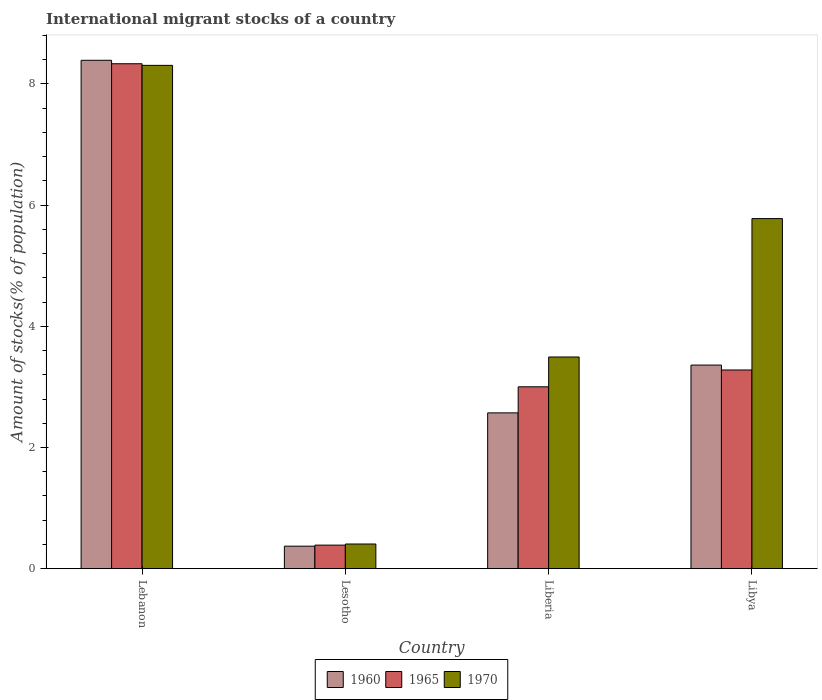How many different coloured bars are there?
Give a very brief answer. 3. How many groups of bars are there?
Your answer should be compact. 4. Are the number of bars on each tick of the X-axis equal?
Your response must be concise. Yes. What is the label of the 1st group of bars from the left?
Offer a terse response. Lebanon. What is the amount of stocks in in 1960 in Lesotho?
Ensure brevity in your answer.  0.37. Across all countries, what is the maximum amount of stocks in in 1970?
Give a very brief answer. 8.31. Across all countries, what is the minimum amount of stocks in in 1965?
Your answer should be very brief. 0.39. In which country was the amount of stocks in in 1970 maximum?
Your answer should be very brief. Lebanon. In which country was the amount of stocks in in 1965 minimum?
Make the answer very short. Lesotho. What is the total amount of stocks in in 1970 in the graph?
Your response must be concise. 17.99. What is the difference between the amount of stocks in in 1960 in Liberia and that in Libya?
Offer a very short reply. -0.79. What is the difference between the amount of stocks in in 1970 in Liberia and the amount of stocks in in 1965 in Lebanon?
Your answer should be very brief. -4.84. What is the average amount of stocks in in 1960 per country?
Give a very brief answer. 3.67. What is the difference between the amount of stocks in of/in 1970 and amount of stocks in of/in 1965 in Lebanon?
Provide a short and direct response. -0.03. What is the ratio of the amount of stocks in in 1960 in Lebanon to that in Lesotho?
Your answer should be compact. 22.57. Is the amount of stocks in in 1965 in Lebanon less than that in Liberia?
Offer a very short reply. No. What is the difference between the highest and the second highest amount of stocks in in 1960?
Your answer should be compact. 5.82. What is the difference between the highest and the lowest amount of stocks in in 1960?
Offer a terse response. 8.02. In how many countries, is the amount of stocks in in 1965 greater than the average amount of stocks in in 1965 taken over all countries?
Your answer should be very brief. 1. What does the 3rd bar from the left in Lesotho represents?
Provide a succinct answer. 1970. What does the 2nd bar from the right in Liberia represents?
Your answer should be very brief. 1965. Is it the case that in every country, the sum of the amount of stocks in in 1970 and amount of stocks in in 1965 is greater than the amount of stocks in in 1960?
Your answer should be very brief. Yes. How many bars are there?
Keep it short and to the point. 12. Are all the bars in the graph horizontal?
Your response must be concise. No. Are the values on the major ticks of Y-axis written in scientific E-notation?
Give a very brief answer. No. Does the graph contain any zero values?
Your answer should be very brief. No. Does the graph contain grids?
Provide a succinct answer. No. Where does the legend appear in the graph?
Offer a very short reply. Bottom center. What is the title of the graph?
Your answer should be very brief. International migrant stocks of a country. Does "1983" appear as one of the legend labels in the graph?
Make the answer very short. No. What is the label or title of the Y-axis?
Your answer should be very brief. Amount of stocks(% of population). What is the Amount of stocks(% of population) of 1960 in Lebanon?
Give a very brief answer. 8.39. What is the Amount of stocks(% of population) of 1965 in Lebanon?
Your answer should be compact. 8.33. What is the Amount of stocks(% of population) of 1970 in Lebanon?
Ensure brevity in your answer.  8.31. What is the Amount of stocks(% of population) of 1960 in Lesotho?
Your answer should be compact. 0.37. What is the Amount of stocks(% of population) of 1965 in Lesotho?
Your answer should be compact. 0.39. What is the Amount of stocks(% of population) in 1970 in Lesotho?
Provide a succinct answer. 0.41. What is the Amount of stocks(% of population) in 1960 in Liberia?
Offer a very short reply. 2.57. What is the Amount of stocks(% of population) in 1965 in Liberia?
Provide a short and direct response. 3. What is the Amount of stocks(% of population) of 1970 in Liberia?
Make the answer very short. 3.49. What is the Amount of stocks(% of population) of 1960 in Libya?
Ensure brevity in your answer.  3.36. What is the Amount of stocks(% of population) in 1965 in Libya?
Your answer should be very brief. 3.28. What is the Amount of stocks(% of population) of 1970 in Libya?
Keep it short and to the point. 5.78. Across all countries, what is the maximum Amount of stocks(% of population) of 1960?
Keep it short and to the point. 8.39. Across all countries, what is the maximum Amount of stocks(% of population) in 1965?
Keep it short and to the point. 8.33. Across all countries, what is the maximum Amount of stocks(% of population) in 1970?
Keep it short and to the point. 8.31. Across all countries, what is the minimum Amount of stocks(% of population) of 1960?
Your answer should be very brief. 0.37. Across all countries, what is the minimum Amount of stocks(% of population) of 1965?
Your answer should be compact. 0.39. Across all countries, what is the minimum Amount of stocks(% of population) of 1970?
Your answer should be compact. 0.41. What is the total Amount of stocks(% of population) of 1960 in the graph?
Offer a very short reply. 14.69. What is the total Amount of stocks(% of population) of 1965 in the graph?
Your answer should be very brief. 15. What is the total Amount of stocks(% of population) in 1970 in the graph?
Keep it short and to the point. 17.99. What is the difference between the Amount of stocks(% of population) in 1960 in Lebanon and that in Lesotho?
Make the answer very short. 8.02. What is the difference between the Amount of stocks(% of population) in 1965 in Lebanon and that in Lesotho?
Your answer should be compact. 7.94. What is the difference between the Amount of stocks(% of population) in 1970 in Lebanon and that in Lesotho?
Offer a very short reply. 7.9. What is the difference between the Amount of stocks(% of population) in 1960 in Lebanon and that in Liberia?
Your response must be concise. 5.82. What is the difference between the Amount of stocks(% of population) in 1965 in Lebanon and that in Liberia?
Keep it short and to the point. 5.33. What is the difference between the Amount of stocks(% of population) in 1970 in Lebanon and that in Liberia?
Provide a succinct answer. 4.81. What is the difference between the Amount of stocks(% of population) of 1960 in Lebanon and that in Libya?
Offer a terse response. 5.03. What is the difference between the Amount of stocks(% of population) of 1965 in Lebanon and that in Libya?
Your response must be concise. 5.05. What is the difference between the Amount of stocks(% of population) of 1970 in Lebanon and that in Libya?
Ensure brevity in your answer.  2.53. What is the difference between the Amount of stocks(% of population) of 1960 in Lesotho and that in Liberia?
Make the answer very short. -2.2. What is the difference between the Amount of stocks(% of population) in 1965 in Lesotho and that in Liberia?
Provide a succinct answer. -2.61. What is the difference between the Amount of stocks(% of population) in 1970 in Lesotho and that in Liberia?
Keep it short and to the point. -3.09. What is the difference between the Amount of stocks(% of population) in 1960 in Lesotho and that in Libya?
Your answer should be very brief. -2.99. What is the difference between the Amount of stocks(% of population) in 1965 in Lesotho and that in Libya?
Your answer should be very brief. -2.89. What is the difference between the Amount of stocks(% of population) in 1970 in Lesotho and that in Libya?
Ensure brevity in your answer.  -5.37. What is the difference between the Amount of stocks(% of population) of 1960 in Liberia and that in Libya?
Provide a short and direct response. -0.79. What is the difference between the Amount of stocks(% of population) of 1965 in Liberia and that in Libya?
Provide a succinct answer. -0.28. What is the difference between the Amount of stocks(% of population) in 1970 in Liberia and that in Libya?
Your answer should be compact. -2.28. What is the difference between the Amount of stocks(% of population) of 1960 in Lebanon and the Amount of stocks(% of population) of 1965 in Lesotho?
Your answer should be very brief. 8. What is the difference between the Amount of stocks(% of population) in 1960 in Lebanon and the Amount of stocks(% of population) in 1970 in Lesotho?
Your answer should be compact. 7.98. What is the difference between the Amount of stocks(% of population) of 1965 in Lebanon and the Amount of stocks(% of population) of 1970 in Lesotho?
Your response must be concise. 7.93. What is the difference between the Amount of stocks(% of population) of 1960 in Lebanon and the Amount of stocks(% of population) of 1965 in Liberia?
Offer a terse response. 5.39. What is the difference between the Amount of stocks(% of population) of 1960 in Lebanon and the Amount of stocks(% of population) of 1970 in Liberia?
Ensure brevity in your answer.  4.9. What is the difference between the Amount of stocks(% of population) of 1965 in Lebanon and the Amount of stocks(% of population) of 1970 in Liberia?
Your answer should be compact. 4.84. What is the difference between the Amount of stocks(% of population) of 1960 in Lebanon and the Amount of stocks(% of population) of 1965 in Libya?
Your answer should be very brief. 5.11. What is the difference between the Amount of stocks(% of population) in 1960 in Lebanon and the Amount of stocks(% of population) in 1970 in Libya?
Provide a short and direct response. 2.61. What is the difference between the Amount of stocks(% of population) of 1965 in Lebanon and the Amount of stocks(% of population) of 1970 in Libya?
Ensure brevity in your answer.  2.56. What is the difference between the Amount of stocks(% of population) of 1960 in Lesotho and the Amount of stocks(% of population) of 1965 in Liberia?
Offer a very short reply. -2.63. What is the difference between the Amount of stocks(% of population) in 1960 in Lesotho and the Amount of stocks(% of population) in 1970 in Liberia?
Provide a short and direct response. -3.12. What is the difference between the Amount of stocks(% of population) in 1965 in Lesotho and the Amount of stocks(% of population) in 1970 in Liberia?
Provide a succinct answer. -3.1. What is the difference between the Amount of stocks(% of population) in 1960 in Lesotho and the Amount of stocks(% of population) in 1965 in Libya?
Provide a short and direct response. -2.91. What is the difference between the Amount of stocks(% of population) in 1960 in Lesotho and the Amount of stocks(% of population) in 1970 in Libya?
Your answer should be very brief. -5.41. What is the difference between the Amount of stocks(% of population) in 1965 in Lesotho and the Amount of stocks(% of population) in 1970 in Libya?
Provide a succinct answer. -5.39. What is the difference between the Amount of stocks(% of population) of 1960 in Liberia and the Amount of stocks(% of population) of 1965 in Libya?
Provide a succinct answer. -0.71. What is the difference between the Amount of stocks(% of population) of 1960 in Liberia and the Amount of stocks(% of population) of 1970 in Libya?
Provide a short and direct response. -3.21. What is the difference between the Amount of stocks(% of population) of 1965 in Liberia and the Amount of stocks(% of population) of 1970 in Libya?
Your response must be concise. -2.78. What is the average Amount of stocks(% of population) of 1960 per country?
Your answer should be compact. 3.67. What is the average Amount of stocks(% of population) of 1965 per country?
Your answer should be very brief. 3.75. What is the average Amount of stocks(% of population) in 1970 per country?
Make the answer very short. 4.5. What is the difference between the Amount of stocks(% of population) in 1960 and Amount of stocks(% of population) in 1965 in Lebanon?
Make the answer very short. 0.06. What is the difference between the Amount of stocks(% of population) of 1960 and Amount of stocks(% of population) of 1970 in Lebanon?
Ensure brevity in your answer.  0.08. What is the difference between the Amount of stocks(% of population) of 1965 and Amount of stocks(% of population) of 1970 in Lebanon?
Your response must be concise. 0.03. What is the difference between the Amount of stocks(% of population) of 1960 and Amount of stocks(% of population) of 1965 in Lesotho?
Give a very brief answer. -0.02. What is the difference between the Amount of stocks(% of population) of 1960 and Amount of stocks(% of population) of 1970 in Lesotho?
Offer a terse response. -0.04. What is the difference between the Amount of stocks(% of population) in 1965 and Amount of stocks(% of population) in 1970 in Lesotho?
Keep it short and to the point. -0.02. What is the difference between the Amount of stocks(% of population) of 1960 and Amount of stocks(% of population) of 1965 in Liberia?
Ensure brevity in your answer.  -0.43. What is the difference between the Amount of stocks(% of population) of 1960 and Amount of stocks(% of population) of 1970 in Liberia?
Your response must be concise. -0.92. What is the difference between the Amount of stocks(% of population) in 1965 and Amount of stocks(% of population) in 1970 in Liberia?
Give a very brief answer. -0.49. What is the difference between the Amount of stocks(% of population) in 1960 and Amount of stocks(% of population) in 1965 in Libya?
Offer a very short reply. 0.08. What is the difference between the Amount of stocks(% of population) of 1960 and Amount of stocks(% of population) of 1970 in Libya?
Your answer should be very brief. -2.42. What is the difference between the Amount of stocks(% of population) in 1965 and Amount of stocks(% of population) in 1970 in Libya?
Your answer should be compact. -2.5. What is the ratio of the Amount of stocks(% of population) in 1960 in Lebanon to that in Lesotho?
Give a very brief answer. 22.57. What is the ratio of the Amount of stocks(% of population) of 1965 in Lebanon to that in Lesotho?
Give a very brief answer. 21.41. What is the ratio of the Amount of stocks(% of population) in 1970 in Lebanon to that in Lesotho?
Offer a very short reply. 20.39. What is the ratio of the Amount of stocks(% of population) in 1960 in Lebanon to that in Liberia?
Your answer should be very brief. 3.26. What is the ratio of the Amount of stocks(% of population) in 1965 in Lebanon to that in Liberia?
Give a very brief answer. 2.78. What is the ratio of the Amount of stocks(% of population) of 1970 in Lebanon to that in Liberia?
Your response must be concise. 2.38. What is the ratio of the Amount of stocks(% of population) of 1960 in Lebanon to that in Libya?
Give a very brief answer. 2.5. What is the ratio of the Amount of stocks(% of population) of 1965 in Lebanon to that in Libya?
Your response must be concise. 2.54. What is the ratio of the Amount of stocks(% of population) of 1970 in Lebanon to that in Libya?
Ensure brevity in your answer.  1.44. What is the ratio of the Amount of stocks(% of population) of 1960 in Lesotho to that in Liberia?
Your answer should be very brief. 0.14. What is the ratio of the Amount of stocks(% of population) in 1965 in Lesotho to that in Liberia?
Make the answer very short. 0.13. What is the ratio of the Amount of stocks(% of population) in 1970 in Lesotho to that in Liberia?
Your answer should be very brief. 0.12. What is the ratio of the Amount of stocks(% of population) of 1960 in Lesotho to that in Libya?
Make the answer very short. 0.11. What is the ratio of the Amount of stocks(% of population) in 1965 in Lesotho to that in Libya?
Offer a terse response. 0.12. What is the ratio of the Amount of stocks(% of population) of 1970 in Lesotho to that in Libya?
Provide a short and direct response. 0.07. What is the ratio of the Amount of stocks(% of population) of 1960 in Liberia to that in Libya?
Keep it short and to the point. 0.77. What is the ratio of the Amount of stocks(% of population) in 1965 in Liberia to that in Libya?
Provide a short and direct response. 0.92. What is the ratio of the Amount of stocks(% of population) of 1970 in Liberia to that in Libya?
Your response must be concise. 0.6. What is the difference between the highest and the second highest Amount of stocks(% of population) in 1960?
Ensure brevity in your answer.  5.03. What is the difference between the highest and the second highest Amount of stocks(% of population) in 1965?
Offer a terse response. 5.05. What is the difference between the highest and the second highest Amount of stocks(% of population) of 1970?
Your answer should be very brief. 2.53. What is the difference between the highest and the lowest Amount of stocks(% of population) in 1960?
Provide a succinct answer. 8.02. What is the difference between the highest and the lowest Amount of stocks(% of population) in 1965?
Your response must be concise. 7.94. What is the difference between the highest and the lowest Amount of stocks(% of population) in 1970?
Provide a short and direct response. 7.9. 